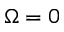<formula> <loc_0><loc_0><loc_500><loc_500>\Omega = 0</formula> 